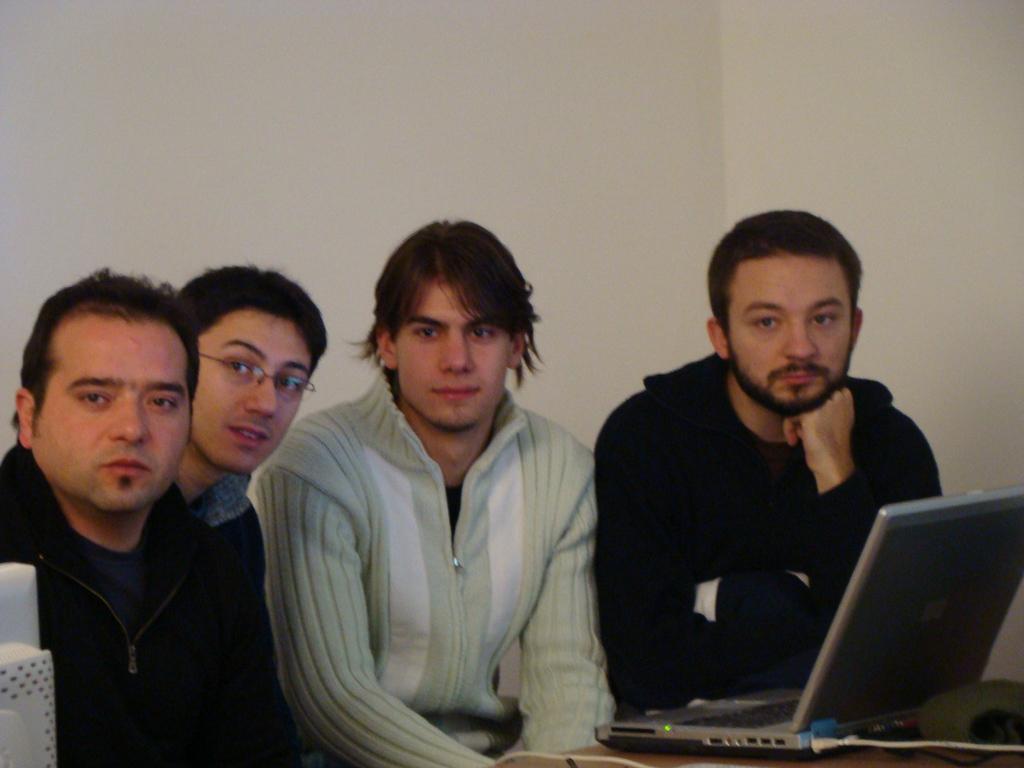Can you describe this image briefly? In this picture we can see a laptop and a few things on the table. We can see four people and the walls in the background. 